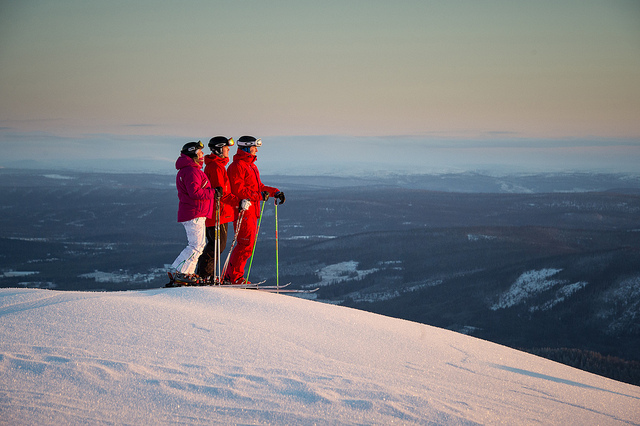What do you think the people in the image might be feeling? While I cannot ascertain their emotions, the three individuals may be feeling a sense of camaraderie and excitement as they share a moment of tranquility and anticipation at the peak before an exhilarating descent. The breathtaking view might also inspire awe and appreciation for the natural beauty surrounding them. 